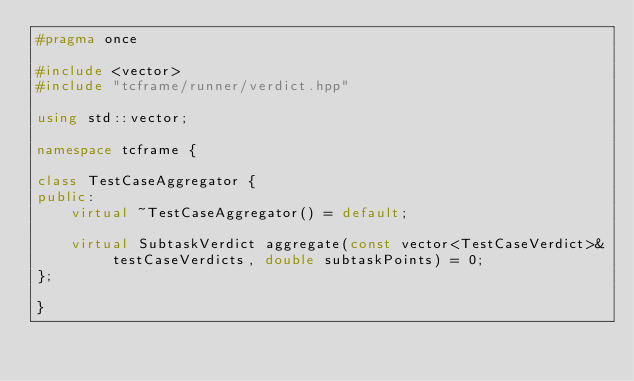<code> <loc_0><loc_0><loc_500><loc_500><_C++_>#pragma once

#include <vector>
#include "tcframe/runner/verdict.hpp"

using std::vector;

namespace tcframe {

class TestCaseAggregator {
public:
    virtual ~TestCaseAggregator() = default;

    virtual SubtaskVerdict aggregate(const vector<TestCaseVerdict>& testCaseVerdicts, double subtaskPoints) = 0;
};

}
</code> 